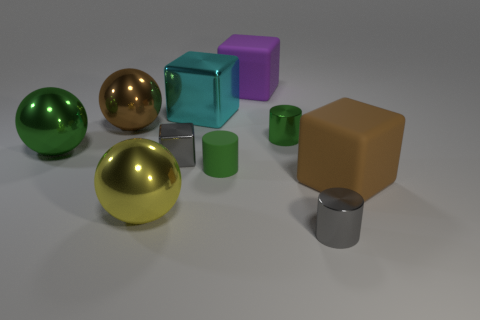There is another small cylinder that is the same color as the matte cylinder; what is it made of?
Offer a very short reply. Metal. There is a large object that is both in front of the large cyan object and behind the big green metallic sphere; what material is it?
Offer a terse response. Metal. How big is the cube that is to the right of the big shiny cube and behind the brown block?
Offer a very short reply. Large. What number of purple objects are cylinders or metal blocks?
Provide a short and direct response. 0. There is a green thing that is the same size as the cyan cube; what is its shape?
Make the answer very short. Sphere. What number of other things are the same color as the rubber cylinder?
Your answer should be very brief. 2. There is a green thing that is in front of the green thing on the left side of the brown ball; what size is it?
Provide a succinct answer. Small. Is the material of the brown thing to the left of the yellow metal object the same as the purple block?
Provide a succinct answer. No. What shape is the small gray thing in front of the big yellow metallic thing?
Offer a terse response. Cylinder. How many metallic spheres are the same size as the gray cube?
Provide a succinct answer. 0. 